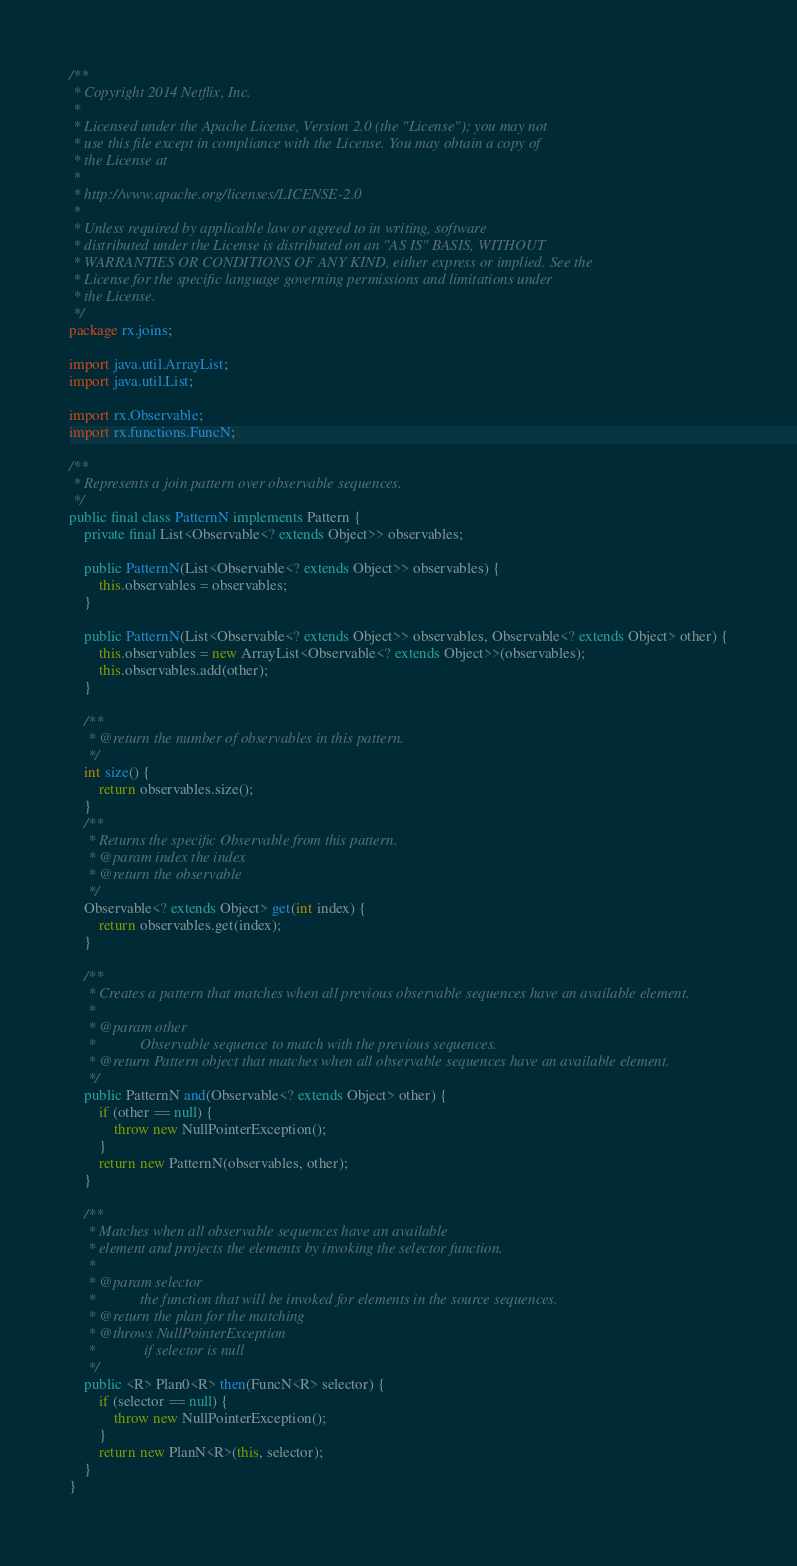Convert code to text. <code><loc_0><loc_0><loc_500><loc_500><_Java_>/**
 * Copyright 2014 Netflix, Inc.
 * 
 * Licensed under the Apache License, Version 2.0 (the "License"); you may not
 * use this file except in compliance with the License. You may obtain a copy of
 * the License at
 * 
 * http://www.apache.org/licenses/LICENSE-2.0
 * 
 * Unless required by applicable law or agreed to in writing, software
 * distributed under the License is distributed on an "AS IS" BASIS, WITHOUT
 * WARRANTIES OR CONDITIONS OF ANY KIND, either express or implied. See the
 * License for the specific language governing permissions and limitations under
 * the License.
 */
package rx.joins;

import java.util.ArrayList;
import java.util.List;

import rx.Observable;
import rx.functions.FuncN;

/**
 * Represents a join pattern over observable sequences.
 */
public final class PatternN implements Pattern {
    private final List<Observable<? extends Object>> observables;

    public PatternN(List<Observable<? extends Object>> observables) {
    	this.observables = observables;
    }

    public PatternN(List<Observable<? extends Object>> observables, Observable<? extends Object> other) {
    	this.observables = new ArrayList<Observable<? extends Object>>(observables);
    	this.observables.add(other);
    }

    /**
     * @return the number of observables in this pattern.
     */
    int size() {
    	return observables.size();
    }
    /**
     * Returns the specific Observable from this pattern.
     * @param index the index
     * @return the observable
     */
    Observable<? extends Object> get(int index) {
    	return observables.get(index);
    }

    /**
     * Creates a pattern that matches when all previous observable sequences have an available element.
     * 
     * @param other
     *            Observable sequence to match with the previous sequences.
     * @return Pattern object that matches when all observable sequences have an available element.
     */
    public PatternN and(Observable<? extends Object> other) {
        if (other == null) {
            throw new NullPointerException();
        }
        return new PatternN(observables, other);
    }
    
    /**
     * Matches when all observable sequences have an available
     * element and projects the elements by invoking the selector function.
     * 
     * @param selector
     *            the function that will be invoked for elements in the source sequences.
     * @return the plan for the matching
     * @throws NullPointerException
     *             if selector is null
     */
    public <R> Plan0<R> then(FuncN<R> selector) {
        if (selector == null) {
            throw new NullPointerException();
        }
        return new PlanN<R>(this, selector);
    }
}
</code> 